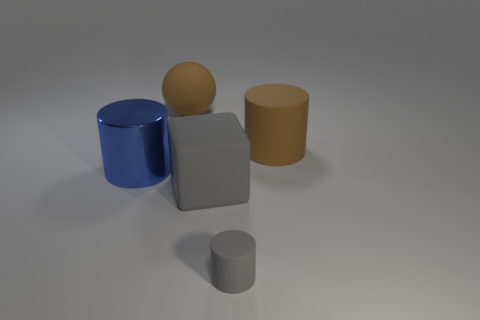Are there any other things that are the same color as the metallic thing?
Keep it short and to the point. No. Are there an equal number of matte cylinders in front of the large blue object and gray cylinders that are right of the small thing?
Provide a short and direct response. No. Are there more tiny gray cylinders that are left of the brown matte cylinder than small gray cylinders?
Your response must be concise. No. What number of things are matte cylinders that are behind the large metallic thing or large shiny things?
Offer a terse response. 2. What number of small cylinders have the same material as the large blue cylinder?
Make the answer very short. 0. What is the shape of the other object that is the same color as the tiny object?
Offer a very short reply. Cube. Are there any tiny yellow things that have the same shape as the tiny gray thing?
Provide a succinct answer. No. What shape is the brown rubber object that is the same size as the brown rubber sphere?
Provide a succinct answer. Cylinder. Do the big block and the rubber sphere that is right of the large shiny thing have the same color?
Make the answer very short. No. What number of objects are left of the object that is to the right of the tiny cylinder?
Your response must be concise. 4. 